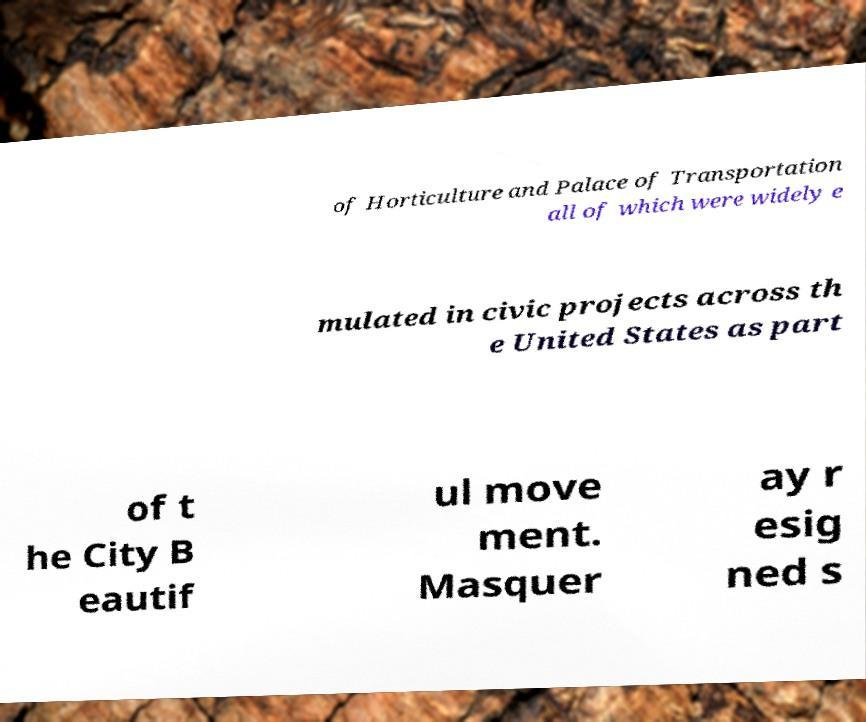Can you read and provide the text displayed in the image?This photo seems to have some interesting text. Can you extract and type it out for me? of Horticulture and Palace of Transportation all of which were widely e mulated in civic projects across th e United States as part of t he City B eautif ul move ment. Masquer ay r esig ned s 